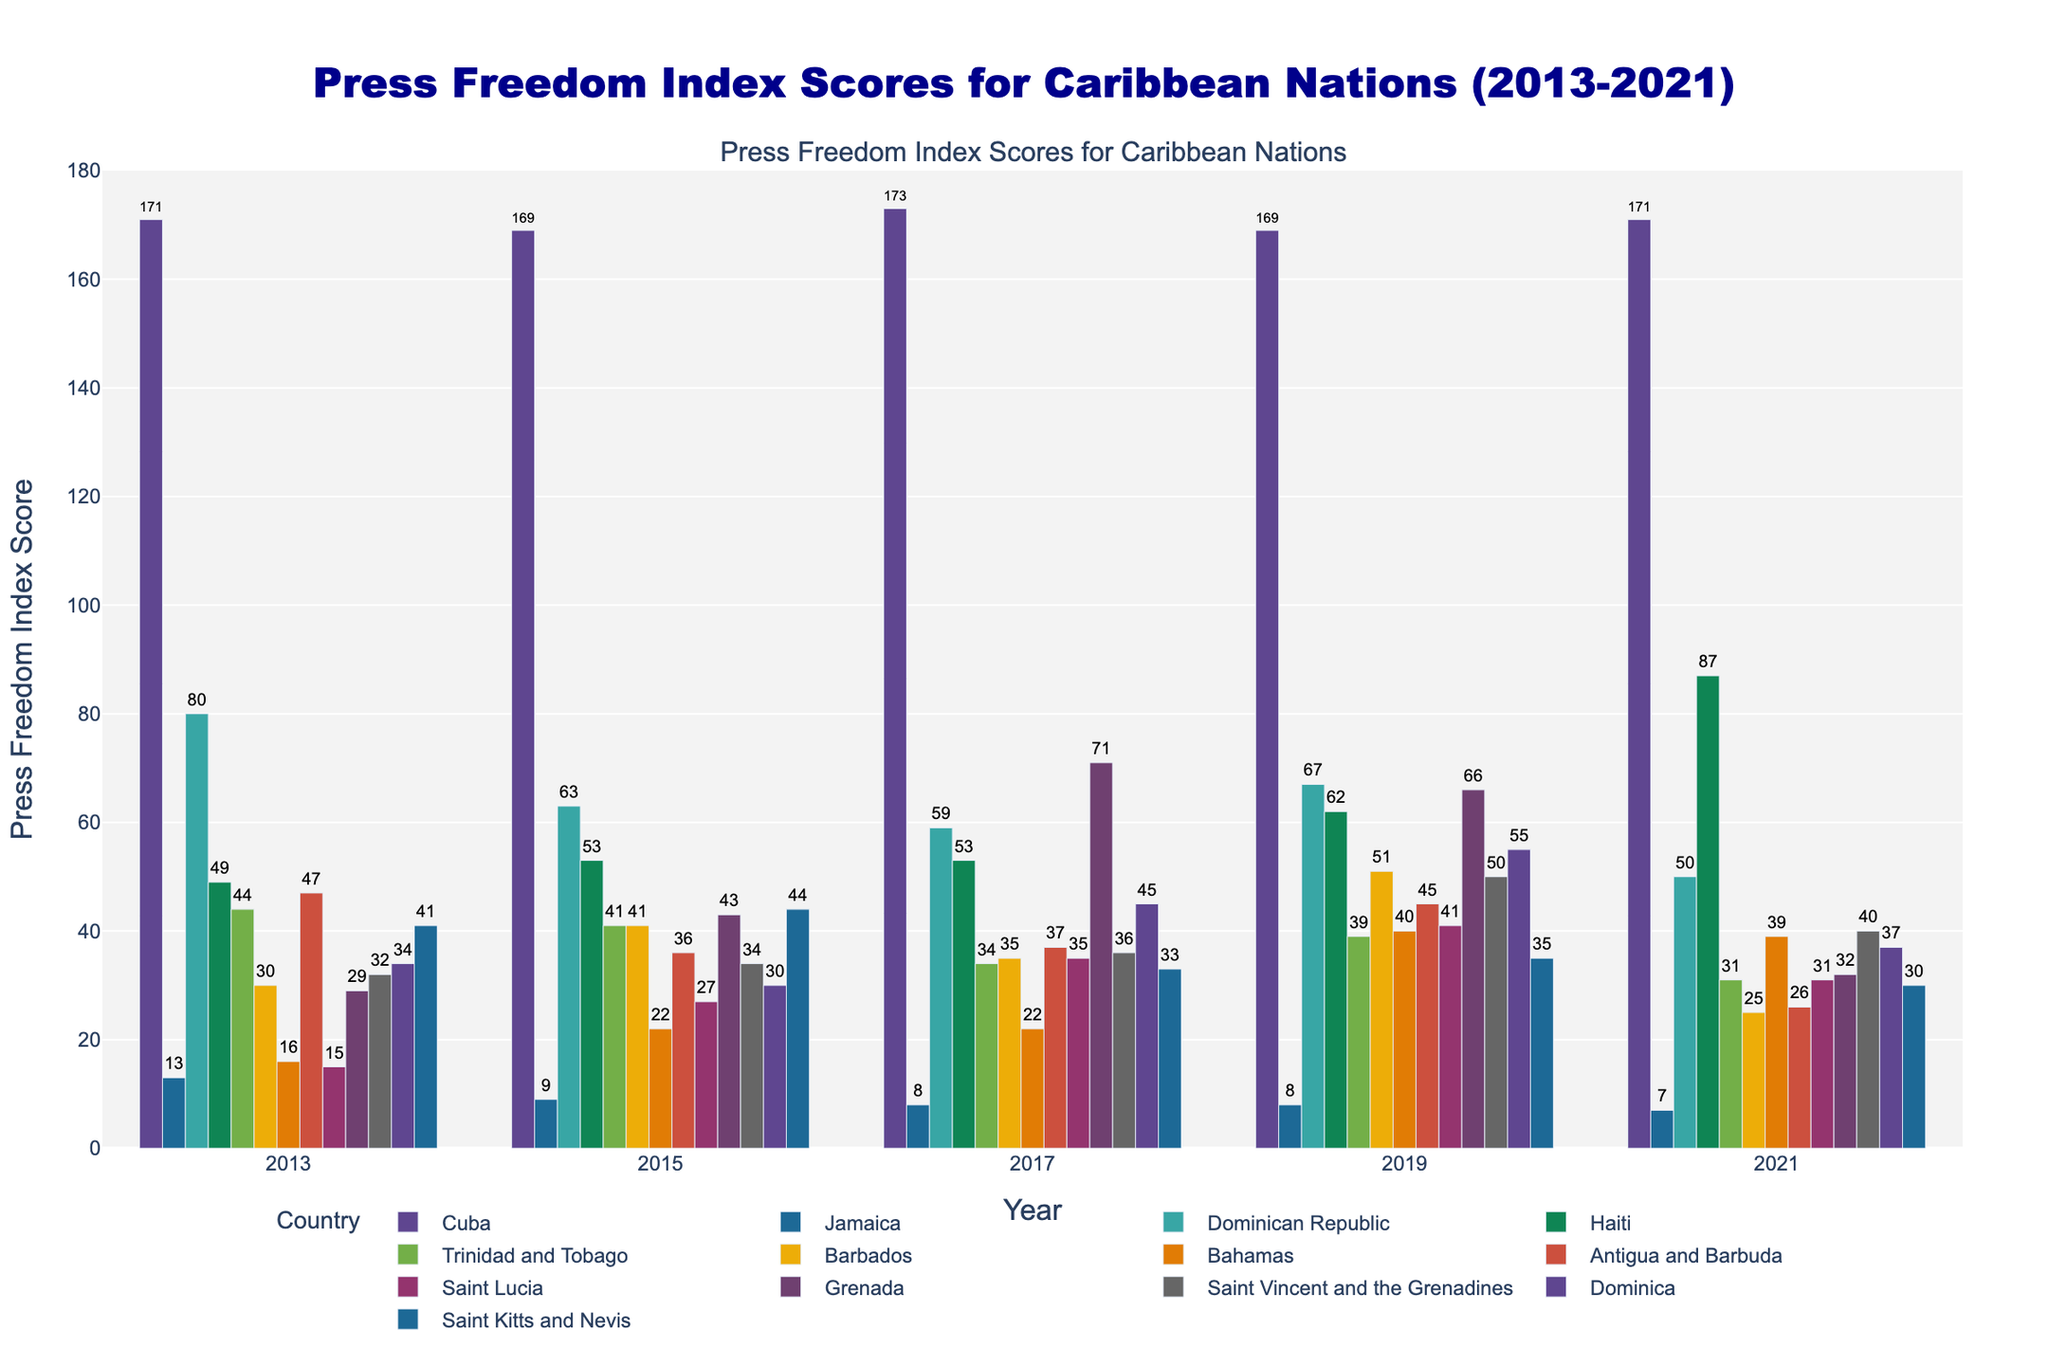What's the trend of press freedom index scores for Cuba over the past decade? To identify the trend, look at Cuba’s scores from 2013 to 2021: 171, 169, 173, 169, and 171. The scores fluctuate within a narrow range, indicating that press freedom has remained consistently low in Cuba.
Answer: Consistently low Which country had the best press freedom index score in 2013? In 2013, Jamaica had the lowest score (13), which indicates the best press freedom index score among the listed countries, as lower scores indicate higher press freedom.
Answer: Jamaica How did Haiti's press freedom index score change from 2019 to 2021? In 2019, Haiti's score was 62, and it increased to 87 in 2021. The difference is 87 - 62 = 25. This increase suggests a decline in press freedom in Haiti during this period.
Answer: Increased by 25 Compare the press freedom index scores of Trinidad and Tobago and Saint Kitts and Nevis in 2017. Which country had better press freedom? In 2017, Trinidad and Tobago had a score of 34, while Saint Kitts and Nevis had a score of 33. A lower score indicates better press freedom, so Saint Kitts and Nevis had slightly better press freedom than Trinidad and Tobago.
Answer: Saint Kitts and Nevis Which country showed the most improvement in press freedom index scores from 2013 to 2021? To find the most improvement, compare the scores of all countries in 2013 and 2021 and calculate the difference. Barbados improved from 30 in 2013 to 25 in 2021, a difference of -5. Many countries improved, but Barbados had the most significant improvement as indicated by the substantial drop in score (lower is better).
Answer: Barbados What is the average press freedom index score for Jamaica over the years provided? To calculate the average score for Jamaica, sum the scores from 2013, 2015, 2017, 2019, and 2021 (13 + 9 + 8 + 8 + 7) and divide by the number of years (5). The sum is 45, so the average is 45 / 5 = 9.
Answer: 9 Which country had the highest increase in press freedom index score between 2017 and 2021? Compare each country's score in 2017 with its score in 2021 to determine the increase. Haiti had an increase from 53 in 2017 to 87 in 2021, the highest increase of 34 points, indicating a decline in press freedom.
Answer: Haiti How many countries had a better (lower) press freedom score in 2021 compared to 2013? Compare the scores for each country in 2013 and 2021. Countries with lower scores in 2021 are Jamaica (13 to 7), Dominican Republic (80 to 50), Trinidad and Tobago (44 to 31), Barbados (30 to 25), Antigua and Barbuda (47 to 26), Grenada (29 to 32), and Saint Kitts and Nevis (41 to 30). That makes 6 countries.
Answer: 6 What was the median press freedom index score for Caribbean nations in 2015? List all scores for 2015 and find the median: 9, 22, 27, 30, 34, 36, 41, 41, 43, 44, 53, 63, 169. The median value is, therefore, 41.
Answer: 41 In which year did the Bahamas have its highest press freedom index score? Looking at the Bahamas scores over the years, the highest score was 40 in 2019, indicating the lowest level of press freedom for that period.
Answer: 2019 